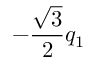Convert formula to latex. <formula><loc_0><loc_0><loc_500><loc_500>- \frac { \sqrt { 3 } } { 2 } q _ { 1 }</formula> 